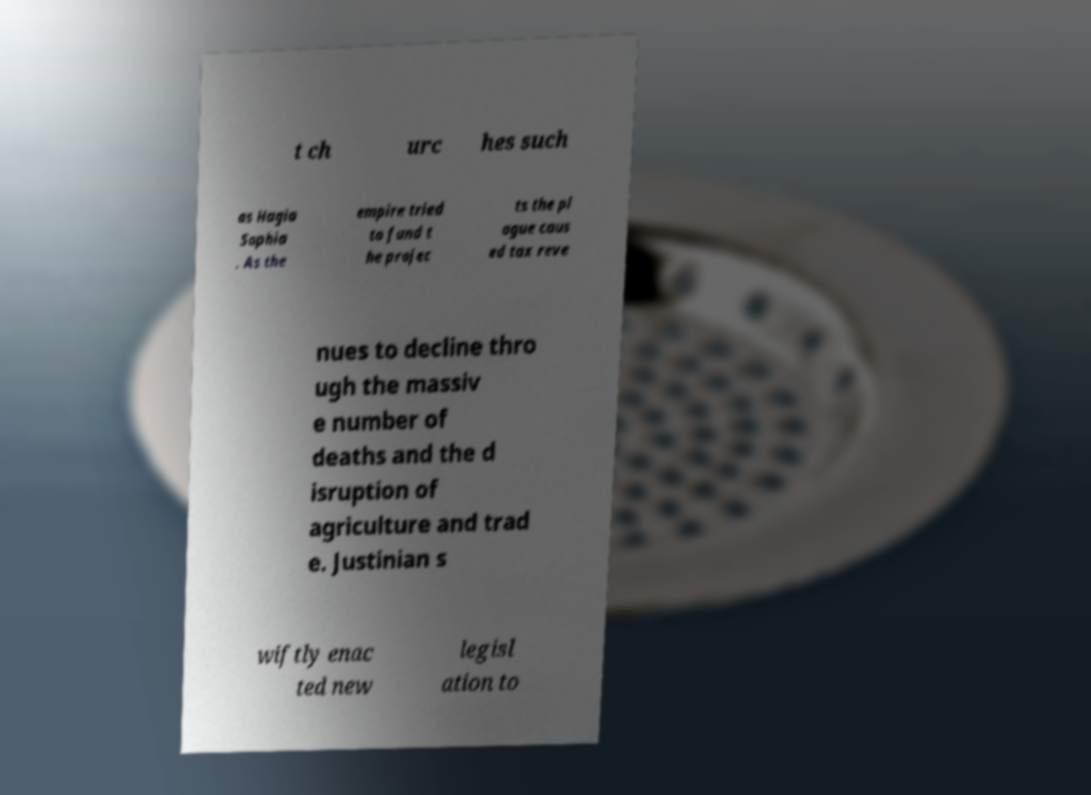Can you read and provide the text displayed in the image?This photo seems to have some interesting text. Can you extract and type it out for me? t ch urc hes such as Hagia Sophia . As the empire tried to fund t he projec ts the pl ague caus ed tax reve nues to decline thro ugh the massiv e number of deaths and the d isruption of agriculture and trad e. Justinian s wiftly enac ted new legisl ation to 